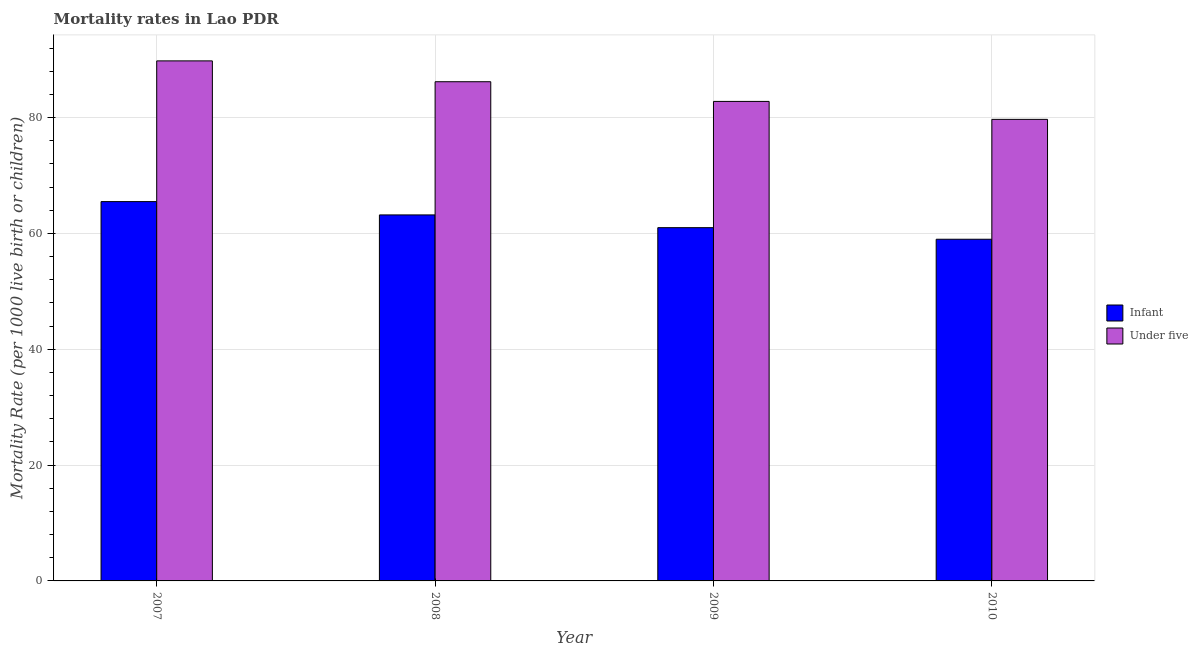How many groups of bars are there?
Ensure brevity in your answer.  4. Are the number of bars on each tick of the X-axis equal?
Give a very brief answer. Yes. How many bars are there on the 4th tick from the left?
Offer a very short reply. 2. In how many cases, is the number of bars for a given year not equal to the number of legend labels?
Provide a succinct answer. 0. What is the under-5 mortality rate in 2010?
Offer a terse response. 79.7. Across all years, what is the maximum under-5 mortality rate?
Your answer should be very brief. 89.8. Across all years, what is the minimum under-5 mortality rate?
Make the answer very short. 79.7. What is the total infant mortality rate in the graph?
Offer a very short reply. 248.7. What is the difference between the infant mortality rate in 2008 and that in 2009?
Your answer should be compact. 2.2. What is the average infant mortality rate per year?
Offer a terse response. 62.17. In how many years, is the infant mortality rate greater than 52?
Provide a succinct answer. 4. What is the ratio of the infant mortality rate in 2008 to that in 2010?
Keep it short and to the point. 1.07. Is the difference between the infant mortality rate in 2007 and 2010 greater than the difference between the under-5 mortality rate in 2007 and 2010?
Offer a terse response. No. What is the difference between the highest and the second highest under-5 mortality rate?
Give a very brief answer. 3.6. What is the difference between the highest and the lowest under-5 mortality rate?
Give a very brief answer. 10.1. In how many years, is the under-5 mortality rate greater than the average under-5 mortality rate taken over all years?
Provide a short and direct response. 2. What does the 2nd bar from the left in 2009 represents?
Your answer should be very brief. Under five. What does the 1st bar from the right in 2010 represents?
Your answer should be compact. Under five. How many bars are there?
Your answer should be compact. 8. Are all the bars in the graph horizontal?
Keep it short and to the point. No. Does the graph contain any zero values?
Make the answer very short. No. Does the graph contain grids?
Ensure brevity in your answer.  Yes. Where does the legend appear in the graph?
Ensure brevity in your answer.  Center right. How many legend labels are there?
Offer a terse response. 2. What is the title of the graph?
Make the answer very short. Mortality rates in Lao PDR. Does "Stunting" appear as one of the legend labels in the graph?
Keep it short and to the point. No. What is the label or title of the Y-axis?
Provide a succinct answer. Mortality Rate (per 1000 live birth or children). What is the Mortality Rate (per 1000 live birth or children) in Infant in 2007?
Make the answer very short. 65.5. What is the Mortality Rate (per 1000 live birth or children) of Under five in 2007?
Keep it short and to the point. 89.8. What is the Mortality Rate (per 1000 live birth or children) of Infant in 2008?
Make the answer very short. 63.2. What is the Mortality Rate (per 1000 live birth or children) in Under five in 2008?
Offer a terse response. 86.2. What is the Mortality Rate (per 1000 live birth or children) in Under five in 2009?
Provide a short and direct response. 82.8. What is the Mortality Rate (per 1000 live birth or children) of Infant in 2010?
Ensure brevity in your answer.  59. What is the Mortality Rate (per 1000 live birth or children) in Under five in 2010?
Give a very brief answer. 79.7. Across all years, what is the maximum Mortality Rate (per 1000 live birth or children) of Infant?
Ensure brevity in your answer.  65.5. Across all years, what is the maximum Mortality Rate (per 1000 live birth or children) of Under five?
Keep it short and to the point. 89.8. Across all years, what is the minimum Mortality Rate (per 1000 live birth or children) of Infant?
Ensure brevity in your answer.  59. Across all years, what is the minimum Mortality Rate (per 1000 live birth or children) of Under five?
Offer a very short reply. 79.7. What is the total Mortality Rate (per 1000 live birth or children) of Infant in the graph?
Your response must be concise. 248.7. What is the total Mortality Rate (per 1000 live birth or children) in Under five in the graph?
Ensure brevity in your answer.  338.5. What is the difference between the Mortality Rate (per 1000 live birth or children) in Infant in 2007 and that in 2008?
Your response must be concise. 2.3. What is the difference between the Mortality Rate (per 1000 live birth or children) of Infant in 2007 and that in 2009?
Provide a succinct answer. 4.5. What is the difference between the Mortality Rate (per 1000 live birth or children) of Infant in 2007 and that in 2010?
Offer a terse response. 6.5. What is the difference between the Mortality Rate (per 1000 live birth or children) in Under five in 2008 and that in 2009?
Offer a terse response. 3.4. What is the difference between the Mortality Rate (per 1000 live birth or children) of Infant in 2008 and that in 2010?
Give a very brief answer. 4.2. What is the difference between the Mortality Rate (per 1000 live birth or children) in Infant in 2007 and the Mortality Rate (per 1000 live birth or children) in Under five in 2008?
Your answer should be compact. -20.7. What is the difference between the Mortality Rate (per 1000 live birth or children) of Infant in 2007 and the Mortality Rate (per 1000 live birth or children) of Under five in 2009?
Your response must be concise. -17.3. What is the difference between the Mortality Rate (per 1000 live birth or children) in Infant in 2007 and the Mortality Rate (per 1000 live birth or children) in Under five in 2010?
Your response must be concise. -14.2. What is the difference between the Mortality Rate (per 1000 live birth or children) of Infant in 2008 and the Mortality Rate (per 1000 live birth or children) of Under five in 2009?
Offer a very short reply. -19.6. What is the difference between the Mortality Rate (per 1000 live birth or children) of Infant in 2008 and the Mortality Rate (per 1000 live birth or children) of Under five in 2010?
Provide a succinct answer. -16.5. What is the difference between the Mortality Rate (per 1000 live birth or children) in Infant in 2009 and the Mortality Rate (per 1000 live birth or children) in Under five in 2010?
Your answer should be very brief. -18.7. What is the average Mortality Rate (per 1000 live birth or children) in Infant per year?
Make the answer very short. 62.17. What is the average Mortality Rate (per 1000 live birth or children) of Under five per year?
Keep it short and to the point. 84.62. In the year 2007, what is the difference between the Mortality Rate (per 1000 live birth or children) of Infant and Mortality Rate (per 1000 live birth or children) of Under five?
Make the answer very short. -24.3. In the year 2008, what is the difference between the Mortality Rate (per 1000 live birth or children) of Infant and Mortality Rate (per 1000 live birth or children) of Under five?
Give a very brief answer. -23. In the year 2009, what is the difference between the Mortality Rate (per 1000 live birth or children) of Infant and Mortality Rate (per 1000 live birth or children) of Under five?
Provide a short and direct response. -21.8. In the year 2010, what is the difference between the Mortality Rate (per 1000 live birth or children) of Infant and Mortality Rate (per 1000 live birth or children) of Under five?
Ensure brevity in your answer.  -20.7. What is the ratio of the Mortality Rate (per 1000 live birth or children) in Infant in 2007 to that in 2008?
Keep it short and to the point. 1.04. What is the ratio of the Mortality Rate (per 1000 live birth or children) in Under five in 2007 to that in 2008?
Make the answer very short. 1.04. What is the ratio of the Mortality Rate (per 1000 live birth or children) of Infant in 2007 to that in 2009?
Offer a very short reply. 1.07. What is the ratio of the Mortality Rate (per 1000 live birth or children) of Under five in 2007 to that in 2009?
Your response must be concise. 1.08. What is the ratio of the Mortality Rate (per 1000 live birth or children) in Infant in 2007 to that in 2010?
Offer a terse response. 1.11. What is the ratio of the Mortality Rate (per 1000 live birth or children) in Under five in 2007 to that in 2010?
Your answer should be compact. 1.13. What is the ratio of the Mortality Rate (per 1000 live birth or children) of Infant in 2008 to that in 2009?
Keep it short and to the point. 1.04. What is the ratio of the Mortality Rate (per 1000 live birth or children) in Under five in 2008 to that in 2009?
Keep it short and to the point. 1.04. What is the ratio of the Mortality Rate (per 1000 live birth or children) in Infant in 2008 to that in 2010?
Provide a succinct answer. 1.07. What is the ratio of the Mortality Rate (per 1000 live birth or children) in Under five in 2008 to that in 2010?
Give a very brief answer. 1.08. What is the ratio of the Mortality Rate (per 1000 live birth or children) of Infant in 2009 to that in 2010?
Your response must be concise. 1.03. What is the ratio of the Mortality Rate (per 1000 live birth or children) in Under five in 2009 to that in 2010?
Your response must be concise. 1.04. What is the difference between the highest and the second highest Mortality Rate (per 1000 live birth or children) of Infant?
Your answer should be compact. 2.3. What is the difference between the highest and the lowest Mortality Rate (per 1000 live birth or children) in Infant?
Your answer should be very brief. 6.5. What is the difference between the highest and the lowest Mortality Rate (per 1000 live birth or children) in Under five?
Ensure brevity in your answer.  10.1. 